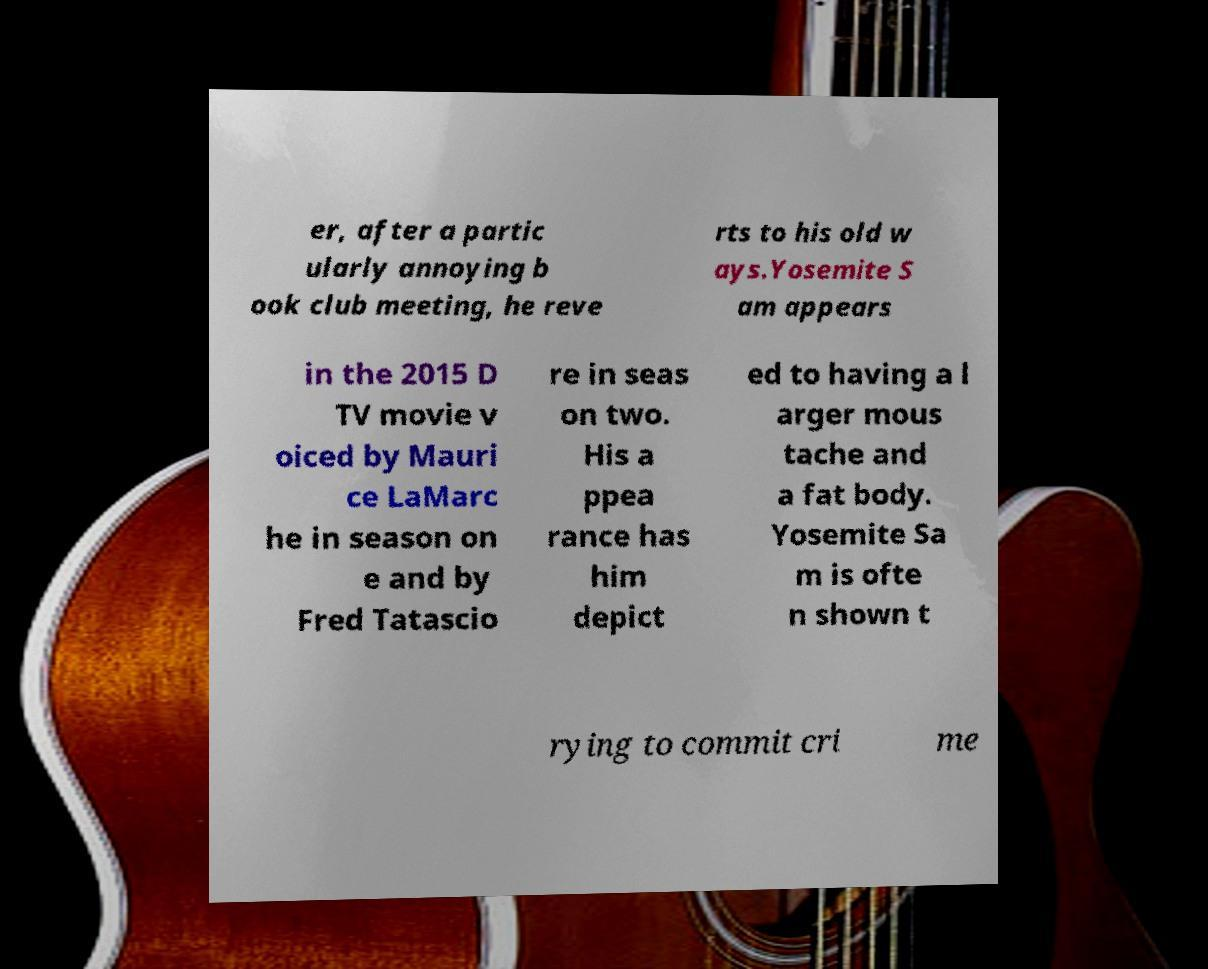For documentation purposes, I need the text within this image transcribed. Could you provide that? er, after a partic ularly annoying b ook club meeting, he reve rts to his old w ays.Yosemite S am appears in the 2015 D TV movie v oiced by Mauri ce LaMarc he in season on e and by Fred Tatascio re in seas on two. His a ppea rance has him depict ed to having a l arger mous tache and a fat body. Yosemite Sa m is ofte n shown t rying to commit cri me 